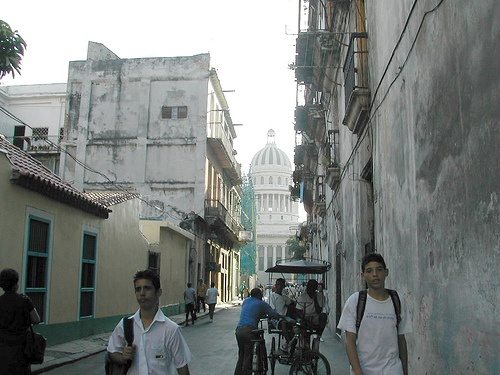Describe the objects in this image and their specific colors. I can see people in white, gray, and black tones, people in white, gray, and black tones, people in white, black, gray, and darkgreen tones, people in white, black, blue, gray, and darkblue tones, and bicycle in white, black, gray, and teal tones in this image. 